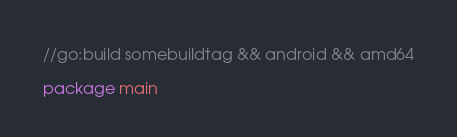<code> <loc_0><loc_0><loc_500><loc_500><_Go_>//go:build somebuildtag && android && amd64

package main
</code> 